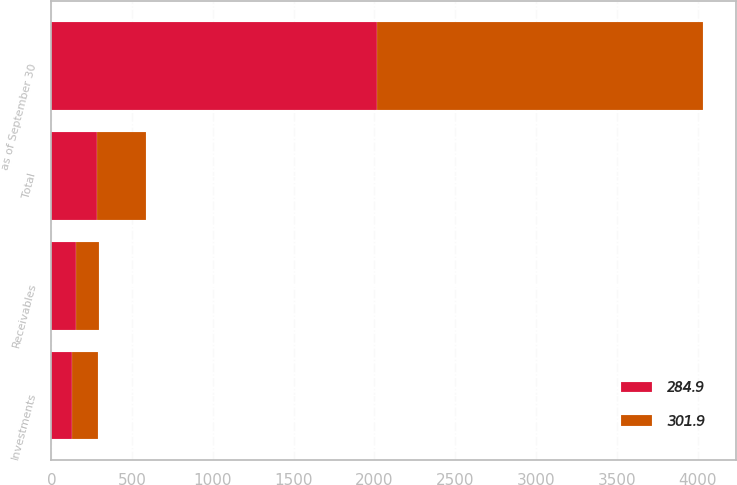Convert chart to OTSL. <chart><loc_0><loc_0><loc_500><loc_500><stacked_bar_chart><ecel><fcel>as of September 30<fcel>Investments<fcel>Receivables<fcel>Total<nl><fcel>301.9<fcel>2018<fcel>161.8<fcel>140.1<fcel>301.9<nl><fcel>284.9<fcel>2017<fcel>129.3<fcel>155.6<fcel>284.9<nl></chart> 